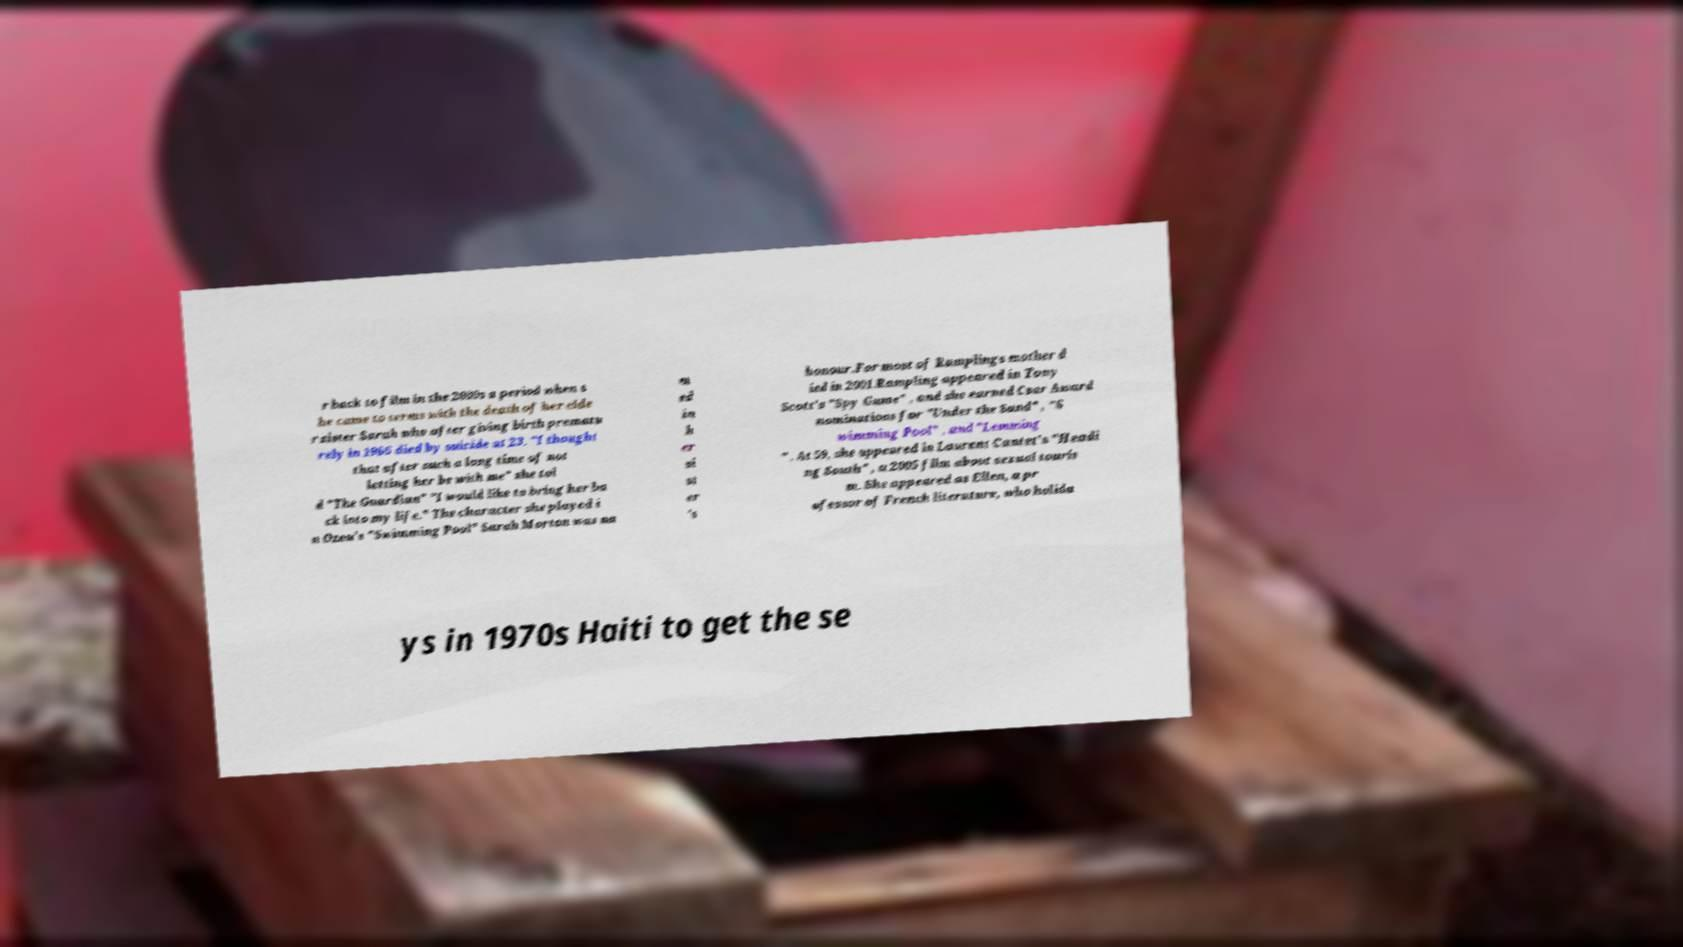Could you extract and type out the text from this image? r back to film in the 2000s a period when s he came to terms with the death of her elde r sister Sarah who after giving birth prematu rely in 1966 died by suicide at 23. "I thought that after such a long time of not letting her be with me" she tol d "The Guardian" "I would like to bring her ba ck into my life." The character she played i n Ozon's "Swimming Pool" Sarah Morton was na m ed in h er si st er 's honour.For most of Ramplings mother d ied in 2001.Rampling appeared in Tony Scott's "Spy Game" , and she earned Csar Award nominations for "Under the Sand" , "S wimming Pool" , and "Lemming " . At 59, she appeared in Laurent Cantet's "Headi ng South" , a 2005 film about sexual touris m. She appeared as Ellen, a pr ofessor of French literature, who holida ys in 1970s Haiti to get the se 